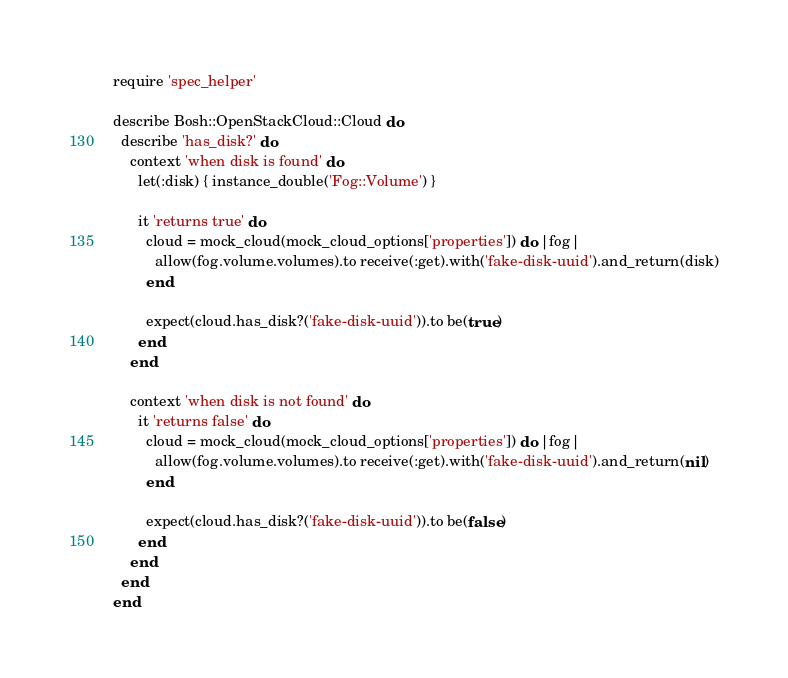Convert code to text. <code><loc_0><loc_0><loc_500><loc_500><_Ruby_>require 'spec_helper'

describe Bosh::OpenStackCloud::Cloud do
  describe 'has_disk?' do
    context 'when disk is found' do
      let(:disk) { instance_double('Fog::Volume') }

      it 'returns true' do
        cloud = mock_cloud(mock_cloud_options['properties']) do |fog|
          allow(fog.volume.volumes).to receive(:get).with('fake-disk-uuid').and_return(disk)
        end

        expect(cloud.has_disk?('fake-disk-uuid')).to be(true)
      end
    end

    context 'when disk is not found' do
      it 'returns false' do
        cloud = mock_cloud(mock_cloud_options['properties']) do |fog|
          allow(fog.volume.volumes).to receive(:get).with('fake-disk-uuid').and_return(nil)
        end

        expect(cloud.has_disk?('fake-disk-uuid')).to be(false)
      end
    end
  end
end
</code> 